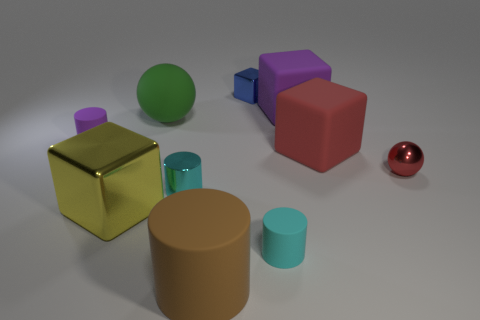Subtract all rubber cylinders. How many cylinders are left? 1 Subtract all purple cylinders. How many cylinders are left? 3 Subtract all yellow blocks. Subtract all yellow balls. How many blocks are left? 3 Subtract all blocks. How many objects are left? 6 Add 7 small cyan rubber things. How many small cyan rubber things exist? 8 Subtract 0 purple spheres. How many objects are left? 10 Subtract all blue matte objects. Subtract all brown cylinders. How many objects are left? 9 Add 5 small cyan metal objects. How many small cyan metal objects are left? 6 